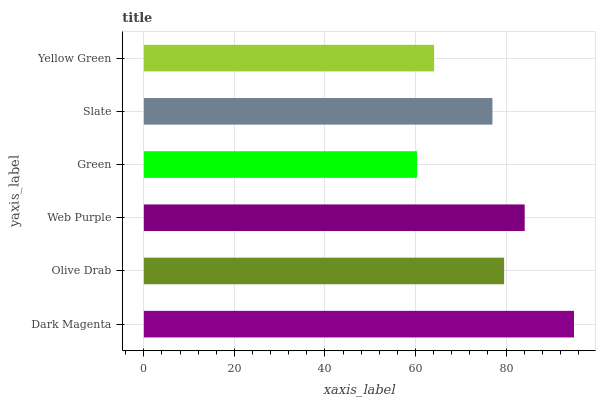Is Green the minimum?
Answer yes or no. Yes. Is Dark Magenta the maximum?
Answer yes or no. Yes. Is Olive Drab the minimum?
Answer yes or no. No. Is Olive Drab the maximum?
Answer yes or no. No. Is Dark Magenta greater than Olive Drab?
Answer yes or no. Yes. Is Olive Drab less than Dark Magenta?
Answer yes or no. Yes. Is Olive Drab greater than Dark Magenta?
Answer yes or no. No. Is Dark Magenta less than Olive Drab?
Answer yes or no. No. Is Olive Drab the high median?
Answer yes or no. Yes. Is Slate the low median?
Answer yes or no. Yes. Is Slate the high median?
Answer yes or no. No. Is Olive Drab the low median?
Answer yes or no. No. 